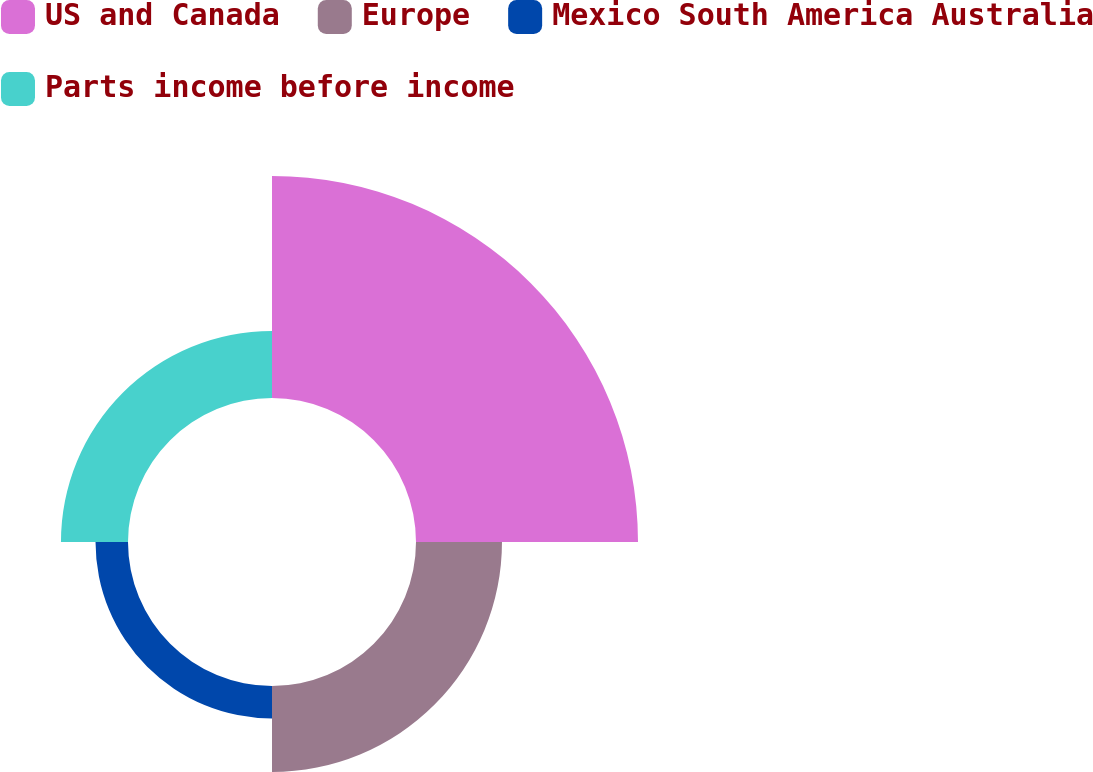Convert chart. <chart><loc_0><loc_0><loc_500><loc_500><pie_chart><fcel>US and Canada<fcel>Europe<fcel>Mexico South America Australia<fcel>Parts income before income<nl><fcel>54.48%<fcel>21.1%<fcel>7.97%<fcel>16.45%<nl></chart> 